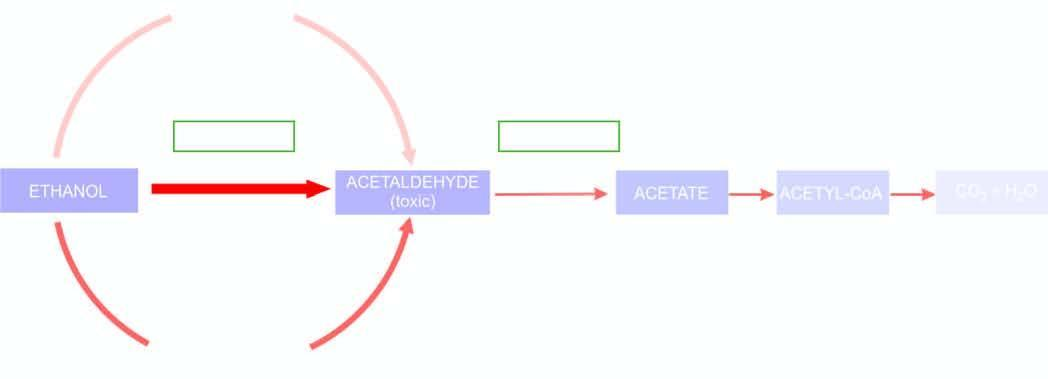does thickness and intensity of colour of arrows on left side of figure correspond to extent of metabolic pathway followed adh = alcohol dehydrogenase ; aldh or acdh = hepatic acetaldehyde dehydrogenase ; nad = nicotinamide adenine dinucleotide ; nadh = r
Answer the question using a single word or phrase. Yes 